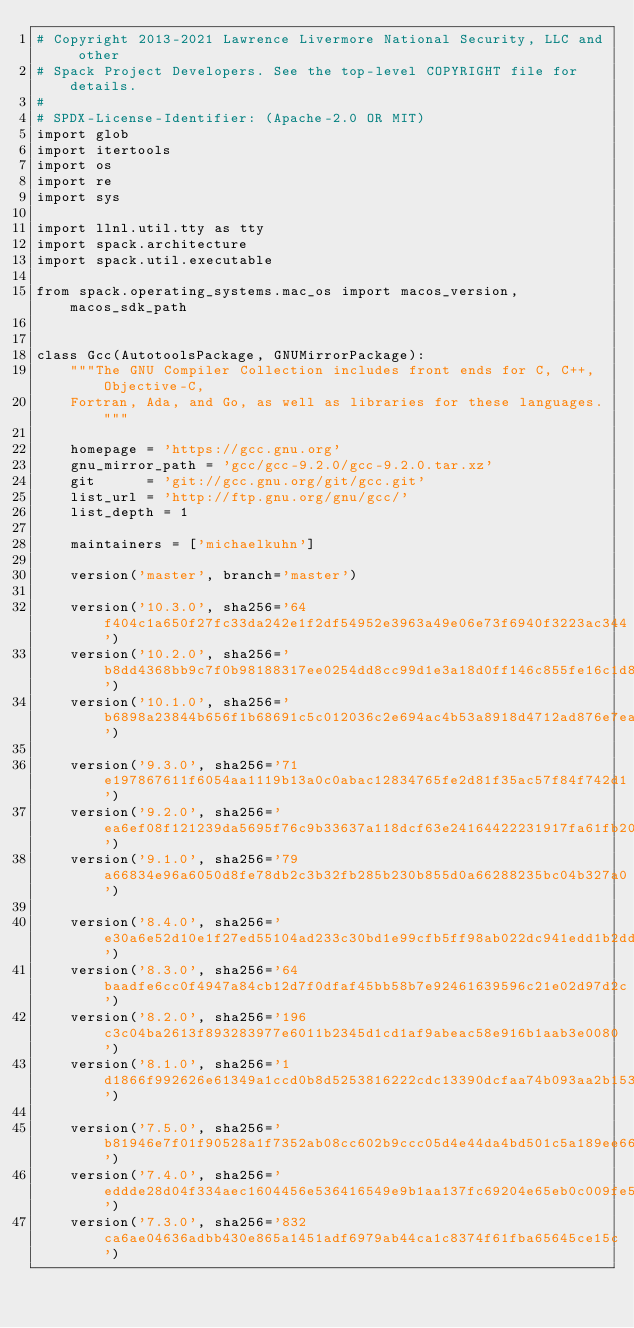<code> <loc_0><loc_0><loc_500><loc_500><_Python_># Copyright 2013-2021 Lawrence Livermore National Security, LLC and other
# Spack Project Developers. See the top-level COPYRIGHT file for details.
#
# SPDX-License-Identifier: (Apache-2.0 OR MIT)
import glob
import itertools
import os
import re
import sys

import llnl.util.tty as tty
import spack.architecture
import spack.util.executable

from spack.operating_systems.mac_os import macos_version, macos_sdk_path


class Gcc(AutotoolsPackage, GNUMirrorPackage):
    """The GNU Compiler Collection includes front ends for C, C++, Objective-C,
    Fortran, Ada, and Go, as well as libraries for these languages."""

    homepage = 'https://gcc.gnu.org'
    gnu_mirror_path = 'gcc/gcc-9.2.0/gcc-9.2.0.tar.xz'
    git      = 'git://gcc.gnu.org/git/gcc.git'
    list_url = 'http://ftp.gnu.org/gnu/gcc/'
    list_depth = 1

    maintainers = ['michaelkuhn']

    version('master', branch='master')

    version('10.3.0', sha256='64f404c1a650f27fc33da242e1f2df54952e3963a49e06e73f6940f3223ac344')
    version('10.2.0', sha256='b8dd4368bb9c7f0b98188317ee0254dd8cc99d1e3a18d0ff146c855fe16c1d8c')
    version('10.1.0', sha256='b6898a23844b656f1b68691c5c012036c2e694ac4b53a8918d4712ad876e7ea2')

    version('9.3.0', sha256='71e197867611f6054aa1119b13a0c0abac12834765fe2d81f35ac57f84f742d1')
    version('9.2.0', sha256='ea6ef08f121239da5695f76c9b33637a118dcf63e24164422231917fa61fb206')
    version('9.1.0', sha256='79a66834e96a6050d8fe78db2c3b32fb285b230b855d0a66288235bc04b327a0')

    version('8.4.0', sha256='e30a6e52d10e1f27ed55104ad233c30bd1e99cfb5ff98ab022dc941edd1b2dd4')
    version('8.3.0', sha256='64baadfe6cc0f4947a84cb12d7f0dfaf45bb58b7e92461639596c21e02d97d2c')
    version('8.2.0', sha256='196c3c04ba2613f893283977e6011b2345d1cd1af9abeac58e916b1aab3e0080')
    version('8.1.0', sha256='1d1866f992626e61349a1ccd0b8d5253816222cdc13390dcfaa74b093aa2b153')

    version('7.5.0', sha256='b81946e7f01f90528a1f7352ab08cc602b9ccc05d4e44da4bd501c5a189ee661')
    version('7.4.0', sha256='eddde28d04f334aec1604456e536416549e9b1aa137fc69204e65eb0c009fe51')
    version('7.3.0', sha256='832ca6ae04636adbb430e865a1451adf6979ab44ca1c8374f61fba65645ce15c')</code> 